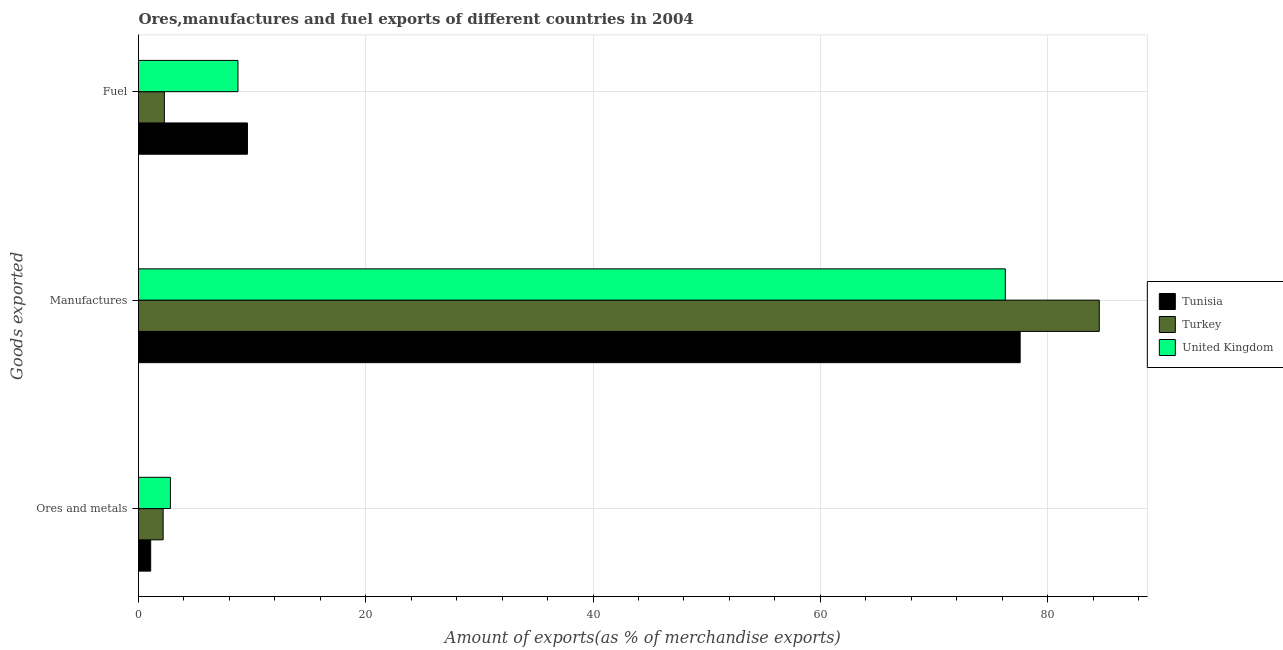How many different coloured bars are there?
Make the answer very short. 3. Are the number of bars per tick equal to the number of legend labels?
Offer a terse response. Yes. How many bars are there on the 2nd tick from the top?
Provide a short and direct response. 3. What is the label of the 2nd group of bars from the top?
Keep it short and to the point. Manufactures. What is the percentage of ores and metals exports in Turkey?
Your answer should be compact. 2.17. Across all countries, what is the maximum percentage of fuel exports?
Ensure brevity in your answer.  9.59. Across all countries, what is the minimum percentage of fuel exports?
Your response must be concise. 2.27. What is the total percentage of ores and metals exports in the graph?
Your response must be concise. 6.04. What is the difference between the percentage of ores and metals exports in Tunisia and that in United Kingdom?
Your response must be concise. -1.74. What is the difference between the percentage of ores and metals exports in Tunisia and the percentage of fuel exports in United Kingdom?
Make the answer very short. -7.68. What is the average percentage of fuel exports per country?
Your answer should be compact. 6.87. What is the difference between the percentage of fuel exports and percentage of manufactures exports in United Kingdom?
Offer a terse response. -67.53. In how many countries, is the percentage of ores and metals exports greater than 40 %?
Your answer should be very brief. 0. What is the ratio of the percentage of manufactures exports in United Kingdom to that in Tunisia?
Offer a very short reply. 0.98. Is the percentage of ores and metals exports in Turkey less than that in Tunisia?
Give a very brief answer. No. What is the difference between the highest and the second highest percentage of manufactures exports?
Ensure brevity in your answer.  6.96. What is the difference between the highest and the lowest percentage of manufactures exports?
Provide a succinct answer. 8.27. In how many countries, is the percentage of ores and metals exports greater than the average percentage of ores and metals exports taken over all countries?
Keep it short and to the point. 2. What does the 1st bar from the bottom in Ores and metals represents?
Keep it short and to the point. Tunisia. What is the difference between two consecutive major ticks on the X-axis?
Provide a succinct answer. 20. Where does the legend appear in the graph?
Your answer should be very brief. Center right. How are the legend labels stacked?
Keep it short and to the point. Vertical. What is the title of the graph?
Provide a succinct answer. Ores,manufactures and fuel exports of different countries in 2004. Does "Ethiopia" appear as one of the legend labels in the graph?
Provide a succinct answer. No. What is the label or title of the X-axis?
Make the answer very short. Amount of exports(as % of merchandise exports). What is the label or title of the Y-axis?
Give a very brief answer. Goods exported. What is the Amount of exports(as % of merchandise exports) of Tunisia in Ores and metals?
Keep it short and to the point. 1.07. What is the Amount of exports(as % of merchandise exports) in Turkey in Ores and metals?
Provide a short and direct response. 2.17. What is the Amount of exports(as % of merchandise exports) in United Kingdom in Ores and metals?
Your answer should be compact. 2.81. What is the Amount of exports(as % of merchandise exports) in Tunisia in Manufactures?
Give a very brief answer. 77.59. What is the Amount of exports(as % of merchandise exports) in Turkey in Manufactures?
Offer a very short reply. 84.55. What is the Amount of exports(as % of merchandise exports) in United Kingdom in Manufactures?
Your answer should be very brief. 76.28. What is the Amount of exports(as % of merchandise exports) of Tunisia in Fuel?
Offer a very short reply. 9.59. What is the Amount of exports(as % of merchandise exports) of Turkey in Fuel?
Your response must be concise. 2.27. What is the Amount of exports(as % of merchandise exports) of United Kingdom in Fuel?
Your answer should be compact. 8.75. Across all Goods exported, what is the maximum Amount of exports(as % of merchandise exports) in Tunisia?
Keep it short and to the point. 77.59. Across all Goods exported, what is the maximum Amount of exports(as % of merchandise exports) in Turkey?
Provide a short and direct response. 84.55. Across all Goods exported, what is the maximum Amount of exports(as % of merchandise exports) in United Kingdom?
Offer a terse response. 76.28. Across all Goods exported, what is the minimum Amount of exports(as % of merchandise exports) of Tunisia?
Offer a very short reply. 1.07. Across all Goods exported, what is the minimum Amount of exports(as % of merchandise exports) in Turkey?
Offer a very short reply. 2.17. Across all Goods exported, what is the minimum Amount of exports(as % of merchandise exports) of United Kingdom?
Ensure brevity in your answer.  2.81. What is the total Amount of exports(as % of merchandise exports) in Tunisia in the graph?
Offer a terse response. 88.25. What is the total Amount of exports(as % of merchandise exports) of Turkey in the graph?
Your response must be concise. 88.99. What is the total Amount of exports(as % of merchandise exports) of United Kingdom in the graph?
Offer a terse response. 87.84. What is the difference between the Amount of exports(as % of merchandise exports) of Tunisia in Ores and metals and that in Manufactures?
Give a very brief answer. -76.52. What is the difference between the Amount of exports(as % of merchandise exports) in Turkey in Ores and metals and that in Manufactures?
Your answer should be compact. -82.38. What is the difference between the Amount of exports(as % of merchandise exports) of United Kingdom in Ores and metals and that in Manufactures?
Offer a terse response. -73.47. What is the difference between the Amount of exports(as % of merchandise exports) of Tunisia in Ores and metals and that in Fuel?
Offer a very short reply. -8.52. What is the difference between the Amount of exports(as % of merchandise exports) of Turkey in Ores and metals and that in Fuel?
Provide a short and direct response. -0.11. What is the difference between the Amount of exports(as % of merchandise exports) of United Kingdom in Ores and metals and that in Fuel?
Ensure brevity in your answer.  -5.95. What is the difference between the Amount of exports(as % of merchandise exports) in Tunisia in Manufactures and that in Fuel?
Offer a terse response. 68. What is the difference between the Amount of exports(as % of merchandise exports) in Turkey in Manufactures and that in Fuel?
Your answer should be very brief. 82.28. What is the difference between the Amount of exports(as % of merchandise exports) of United Kingdom in Manufactures and that in Fuel?
Keep it short and to the point. 67.53. What is the difference between the Amount of exports(as % of merchandise exports) of Tunisia in Ores and metals and the Amount of exports(as % of merchandise exports) of Turkey in Manufactures?
Ensure brevity in your answer.  -83.48. What is the difference between the Amount of exports(as % of merchandise exports) in Tunisia in Ores and metals and the Amount of exports(as % of merchandise exports) in United Kingdom in Manufactures?
Ensure brevity in your answer.  -75.21. What is the difference between the Amount of exports(as % of merchandise exports) in Turkey in Ores and metals and the Amount of exports(as % of merchandise exports) in United Kingdom in Manufactures?
Your response must be concise. -74.11. What is the difference between the Amount of exports(as % of merchandise exports) in Tunisia in Ores and metals and the Amount of exports(as % of merchandise exports) in Turkey in Fuel?
Offer a very short reply. -1.2. What is the difference between the Amount of exports(as % of merchandise exports) in Tunisia in Ores and metals and the Amount of exports(as % of merchandise exports) in United Kingdom in Fuel?
Your answer should be very brief. -7.68. What is the difference between the Amount of exports(as % of merchandise exports) of Turkey in Ores and metals and the Amount of exports(as % of merchandise exports) of United Kingdom in Fuel?
Your answer should be compact. -6.59. What is the difference between the Amount of exports(as % of merchandise exports) in Tunisia in Manufactures and the Amount of exports(as % of merchandise exports) in Turkey in Fuel?
Keep it short and to the point. 75.31. What is the difference between the Amount of exports(as % of merchandise exports) in Tunisia in Manufactures and the Amount of exports(as % of merchandise exports) in United Kingdom in Fuel?
Give a very brief answer. 68.83. What is the difference between the Amount of exports(as % of merchandise exports) in Turkey in Manufactures and the Amount of exports(as % of merchandise exports) in United Kingdom in Fuel?
Make the answer very short. 75.8. What is the average Amount of exports(as % of merchandise exports) of Tunisia per Goods exported?
Provide a short and direct response. 29.42. What is the average Amount of exports(as % of merchandise exports) in Turkey per Goods exported?
Give a very brief answer. 29.66. What is the average Amount of exports(as % of merchandise exports) in United Kingdom per Goods exported?
Make the answer very short. 29.28. What is the difference between the Amount of exports(as % of merchandise exports) of Tunisia and Amount of exports(as % of merchandise exports) of Turkey in Ores and metals?
Give a very brief answer. -1.1. What is the difference between the Amount of exports(as % of merchandise exports) in Tunisia and Amount of exports(as % of merchandise exports) in United Kingdom in Ores and metals?
Provide a short and direct response. -1.74. What is the difference between the Amount of exports(as % of merchandise exports) in Turkey and Amount of exports(as % of merchandise exports) in United Kingdom in Ores and metals?
Your answer should be very brief. -0.64. What is the difference between the Amount of exports(as % of merchandise exports) of Tunisia and Amount of exports(as % of merchandise exports) of Turkey in Manufactures?
Provide a succinct answer. -6.96. What is the difference between the Amount of exports(as % of merchandise exports) in Tunisia and Amount of exports(as % of merchandise exports) in United Kingdom in Manufactures?
Keep it short and to the point. 1.31. What is the difference between the Amount of exports(as % of merchandise exports) of Turkey and Amount of exports(as % of merchandise exports) of United Kingdom in Manufactures?
Keep it short and to the point. 8.27. What is the difference between the Amount of exports(as % of merchandise exports) of Tunisia and Amount of exports(as % of merchandise exports) of Turkey in Fuel?
Keep it short and to the point. 7.31. What is the difference between the Amount of exports(as % of merchandise exports) in Tunisia and Amount of exports(as % of merchandise exports) in United Kingdom in Fuel?
Your response must be concise. 0.83. What is the difference between the Amount of exports(as % of merchandise exports) in Turkey and Amount of exports(as % of merchandise exports) in United Kingdom in Fuel?
Offer a very short reply. -6.48. What is the ratio of the Amount of exports(as % of merchandise exports) in Tunisia in Ores and metals to that in Manufactures?
Provide a short and direct response. 0.01. What is the ratio of the Amount of exports(as % of merchandise exports) of Turkey in Ores and metals to that in Manufactures?
Give a very brief answer. 0.03. What is the ratio of the Amount of exports(as % of merchandise exports) of United Kingdom in Ores and metals to that in Manufactures?
Make the answer very short. 0.04. What is the ratio of the Amount of exports(as % of merchandise exports) of Tunisia in Ores and metals to that in Fuel?
Provide a short and direct response. 0.11. What is the ratio of the Amount of exports(as % of merchandise exports) of Turkey in Ores and metals to that in Fuel?
Offer a terse response. 0.95. What is the ratio of the Amount of exports(as % of merchandise exports) of United Kingdom in Ores and metals to that in Fuel?
Provide a succinct answer. 0.32. What is the ratio of the Amount of exports(as % of merchandise exports) in Tunisia in Manufactures to that in Fuel?
Offer a very short reply. 8.09. What is the ratio of the Amount of exports(as % of merchandise exports) in Turkey in Manufactures to that in Fuel?
Your response must be concise. 37.18. What is the ratio of the Amount of exports(as % of merchandise exports) of United Kingdom in Manufactures to that in Fuel?
Your answer should be compact. 8.71. What is the difference between the highest and the second highest Amount of exports(as % of merchandise exports) of Tunisia?
Make the answer very short. 68. What is the difference between the highest and the second highest Amount of exports(as % of merchandise exports) of Turkey?
Offer a very short reply. 82.28. What is the difference between the highest and the second highest Amount of exports(as % of merchandise exports) in United Kingdom?
Your answer should be very brief. 67.53. What is the difference between the highest and the lowest Amount of exports(as % of merchandise exports) in Tunisia?
Your answer should be very brief. 76.52. What is the difference between the highest and the lowest Amount of exports(as % of merchandise exports) of Turkey?
Your response must be concise. 82.38. What is the difference between the highest and the lowest Amount of exports(as % of merchandise exports) of United Kingdom?
Provide a short and direct response. 73.47. 